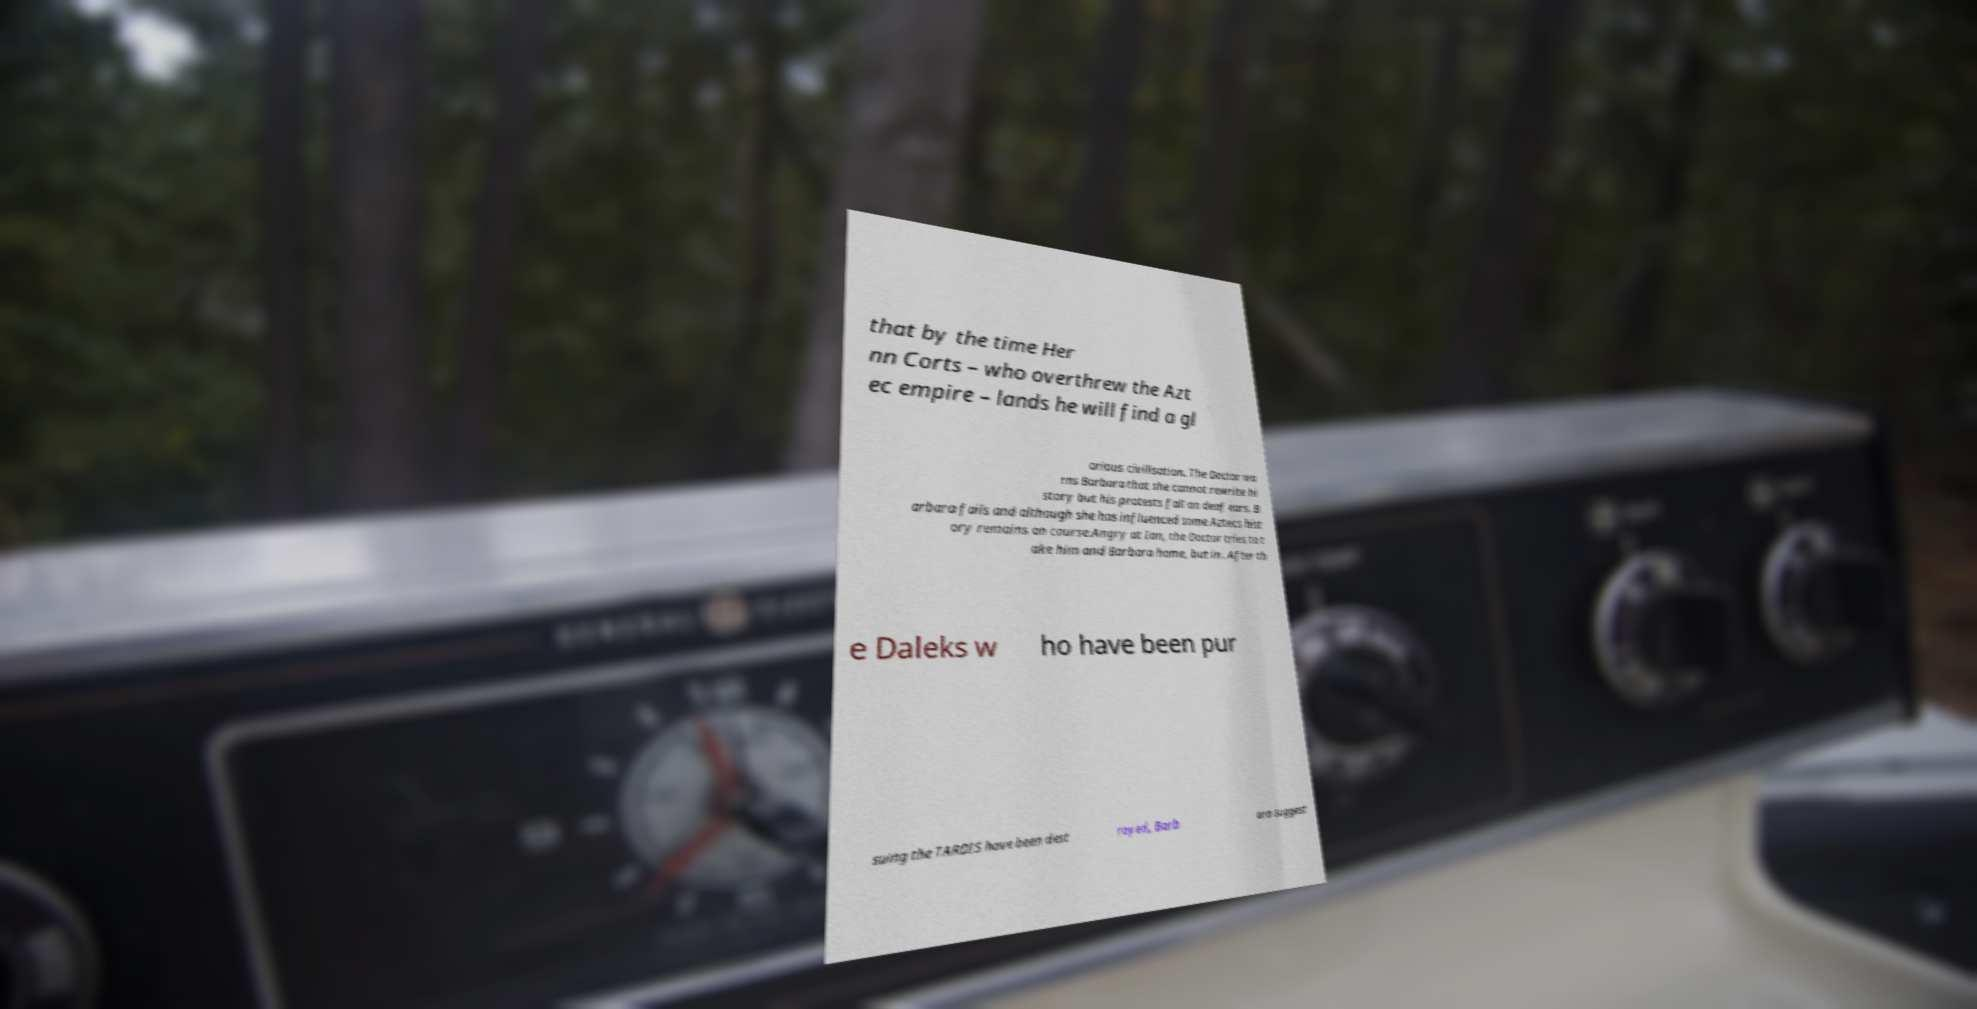For documentation purposes, I need the text within this image transcribed. Could you provide that? that by the time Her nn Corts – who overthrew the Azt ec empire – lands he will find a gl orious civilisation. The Doctor wa rns Barbara that she cannot rewrite hi story but his protests fall on deaf ears. B arbara fails and although she has influenced some Aztecs hist ory remains on course.Angry at Ian, the Doctor tries to t ake him and Barbara home, but in . After th e Daleks w ho have been pur suing the TARDIS have been dest royed, Barb ara suggest 